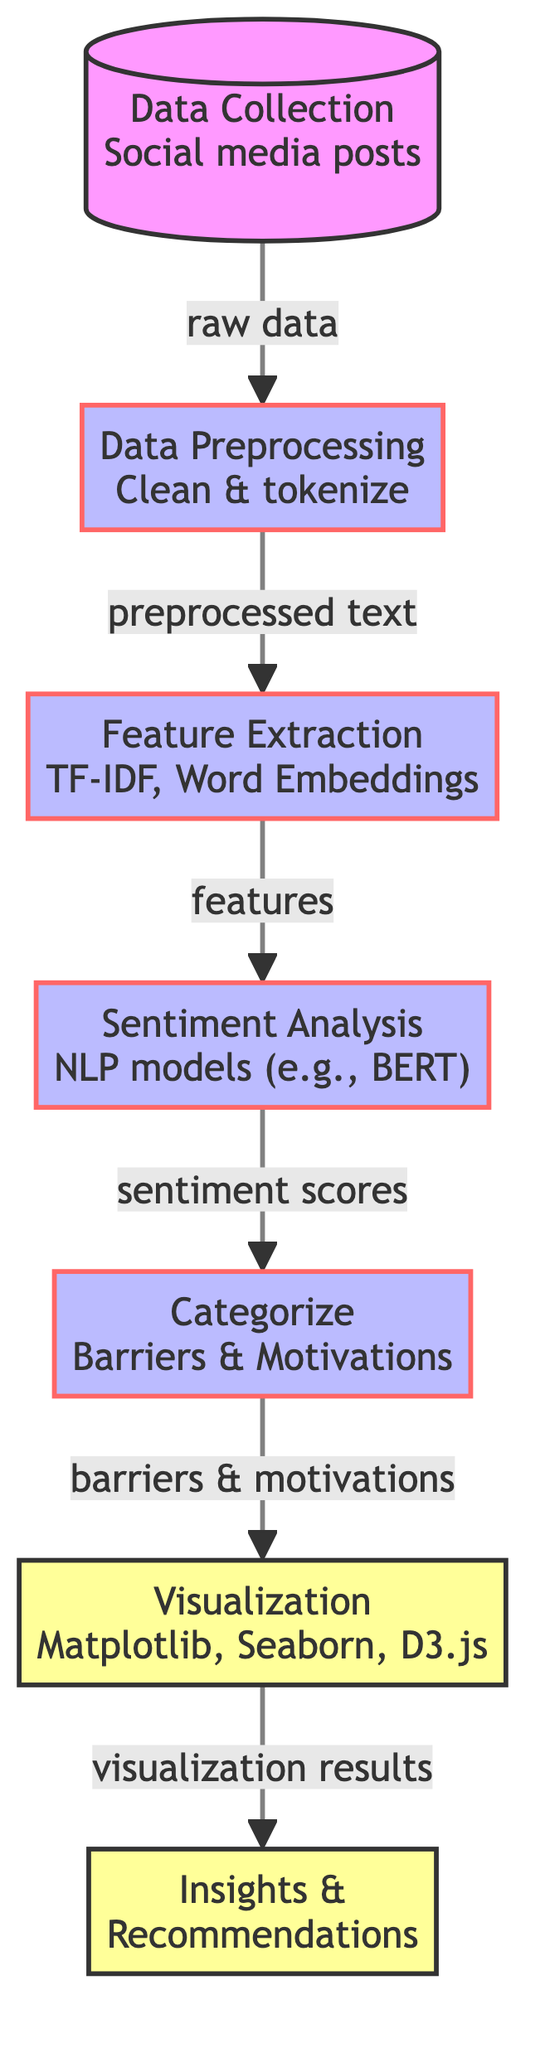What is the first step in the process? The first step in the process is "Data Collection" which involves gathering social media posts. This is indicated as the first node in the diagram.
Answer: Data Collection How many total processes are depicted in the diagram? There are five process nodes represented in the diagram (Data Preprocessing, Feature Extraction, Sentiment Analysis, Categorize, and Visualization). This can be counted by identifying all the nodes labeled as processes.
Answer: Five What is the output of the "Categorize" step? The output of the "Categorize" step is "Barriers & Motivations" as indicated in the diagram. This shows what result comes from categorizing the processed data.
Answer: Barriers & Motivations Which technique is used for sentiment analysis according to the diagram? The technique used for sentiment analysis is "NLP models (e.g., BERT)" which is specified at the corresponding node in the diagram.
Answer: NLP models (e.g., BERT) What is the last output of the process? The last output of the process is "Insights & Recommendations", as shown in the final output node of the diagram. This represents the actionable outcomes derived from the visualized results.
Answer: Insights & Recommendations What connects the "Feature Extraction" step and the "Sentiment Analysis" step? The connection between the "Feature Extraction" step and the "Sentiment Analysis" step is the output labeled "features", which flows from the third node to the fourth node in the diagram's flow.
Answer: Features What visualization tools are mentioned in the diagram? The visualization tools mentioned in the diagram are "Matplotlib, Seaborn, D3.js", which are listed at the visualization step. This indicates the tools used for creating visual representations of the data.
Answer: Matplotlib, Seaborn, D3.js Which step follows "Data Preprocessing" in the flow? The step that follows "Data Preprocessing" is "Feature Extraction", as indicated by the directional flow in the diagram that connects the two nodes.
Answer: Feature Extraction What is the connection type that links the nodes labeled as default? The connection type linking the nodes labeled as default is an edge marked as "raw data", which shows the data flow from the "Data Collection" node to the "Data Preprocessing" node.
Answer: Raw data 